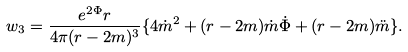<formula> <loc_0><loc_0><loc_500><loc_500>w _ { 3 } = \frac { e ^ { 2 \Phi } r } { 4 \pi ( r - 2 m ) ^ { 3 } } \{ 4 \dot { m } ^ { 2 } + ( r - 2 m ) \dot { m } \dot { \Phi } + ( r - 2 m ) \ddot { m } \} .</formula> 